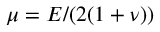<formula> <loc_0><loc_0><loc_500><loc_500>\mu = E / ( 2 ( 1 + \nu ) )</formula> 